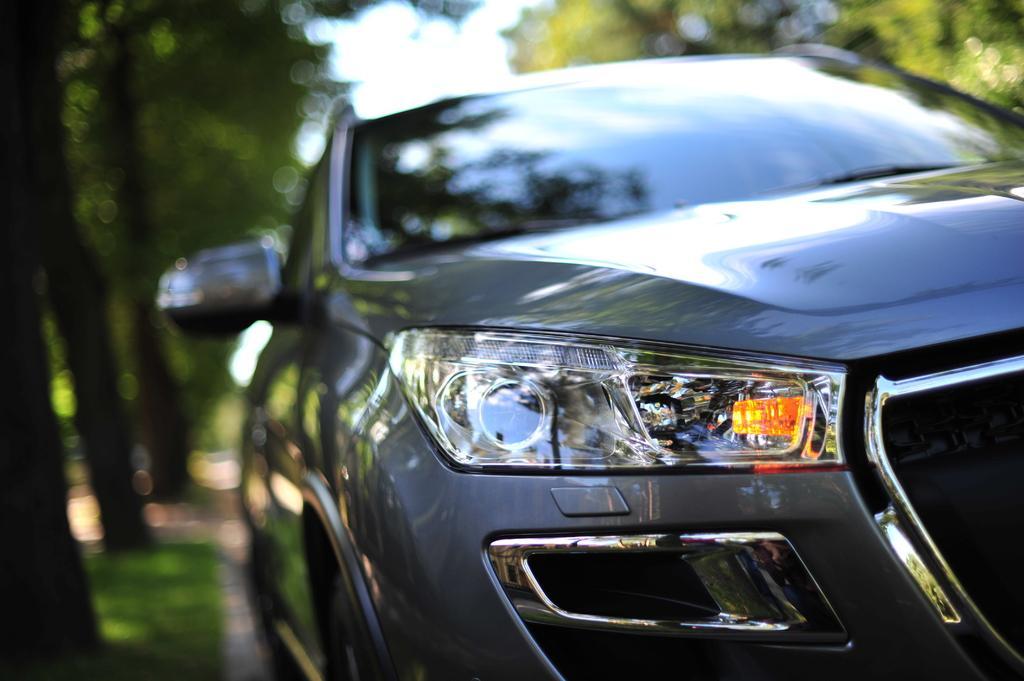Please provide a concise description of this image. In the center of the image there is a car on the road. In the background we can see trees and sky. 